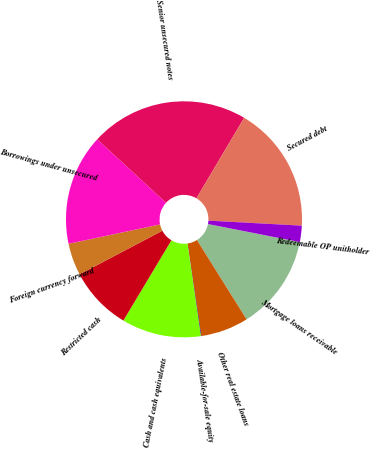<chart> <loc_0><loc_0><loc_500><loc_500><pie_chart><fcel>Mortgage loans receivable<fcel>Other real estate loans<fcel>Available-for-sale equity<fcel>Cash and cash equivalents<fcel>Restricted cash<fcel>Foreign currency forward<fcel>Borrowings under unsecured<fcel>Senior unsecured notes<fcel>Secured debt<fcel>Redeemable OP unitholder<nl><fcel>13.02%<fcel>6.55%<fcel>0.07%<fcel>10.86%<fcel>8.7%<fcel>4.39%<fcel>15.18%<fcel>21.66%<fcel>17.34%<fcel>2.23%<nl></chart> 